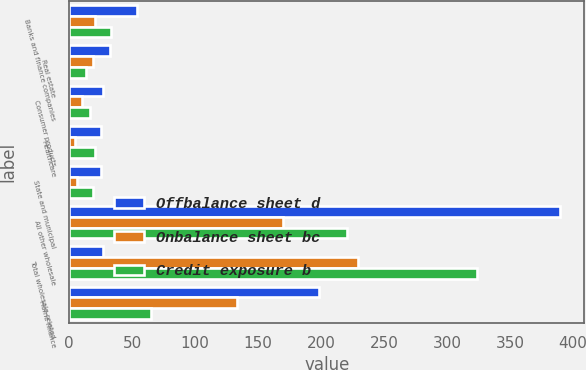Convert chart. <chart><loc_0><loc_0><loc_500><loc_500><stacked_bar_chart><ecel><fcel>Banks and finance companies<fcel>Real estate<fcel>Consumer products<fcel>Healthcare<fcel>State and municipal<fcel>All other wholesale<fcel>Total wholesale-related<fcel>Home finance<nl><fcel>Offbalance sheet d<fcel>53.7<fcel>32.5<fcel>26.7<fcel>25.5<fcel>25.3<fcel>389.7<fcel>26.7<fcel>198.6<nl><fcel>Onbalance sheet bc<fcel>20.3<fcel>19<fcel>10<fcel>4.7<fcel>6.1<fcel>169.5<fcel>229.6<fcel>133.5<nl><fcel>Credit exposure b<fcel>33.4<fcel>13.5<fcel>16.7<fcel>20.8<fcel>19.2<fcel>220.2<fcel>323.8<fcel>65.1<nl></chart> 